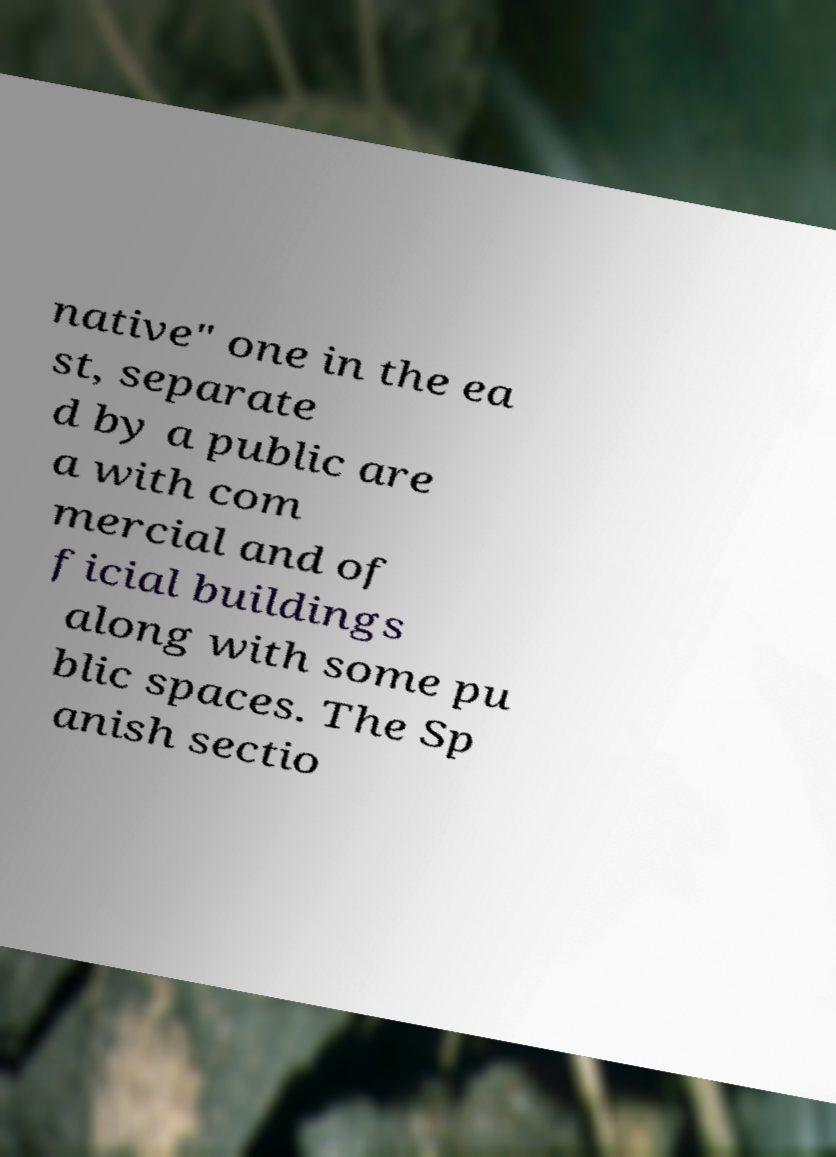Please identify and transcribe the text found in this image. native" one in the ea st, separate d by a public are a with com mercial and of ficial buildings along with some pu blic spaces. The Sp anish sectio 